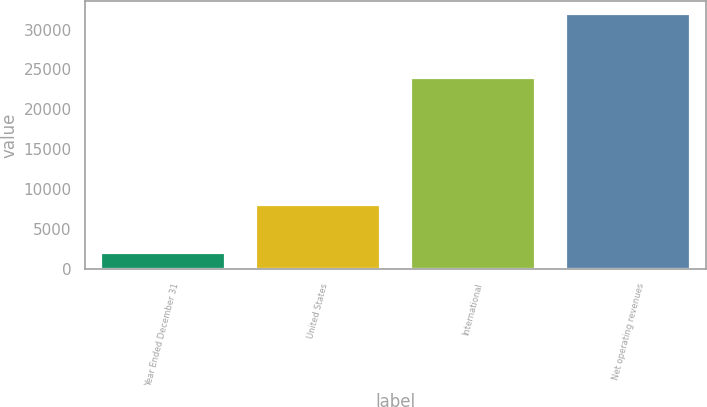Convert chart to OTSL. <chart><loc_0><loc_0><loc_500><loc_500><bar_chart><fcel>Year Ended December 31<fcel>United States<fcel>International<fcel>Net operating revenues<nl><fcel>2008<fcel>8014<fcel>23930<fcel>31944<nl></chart> 